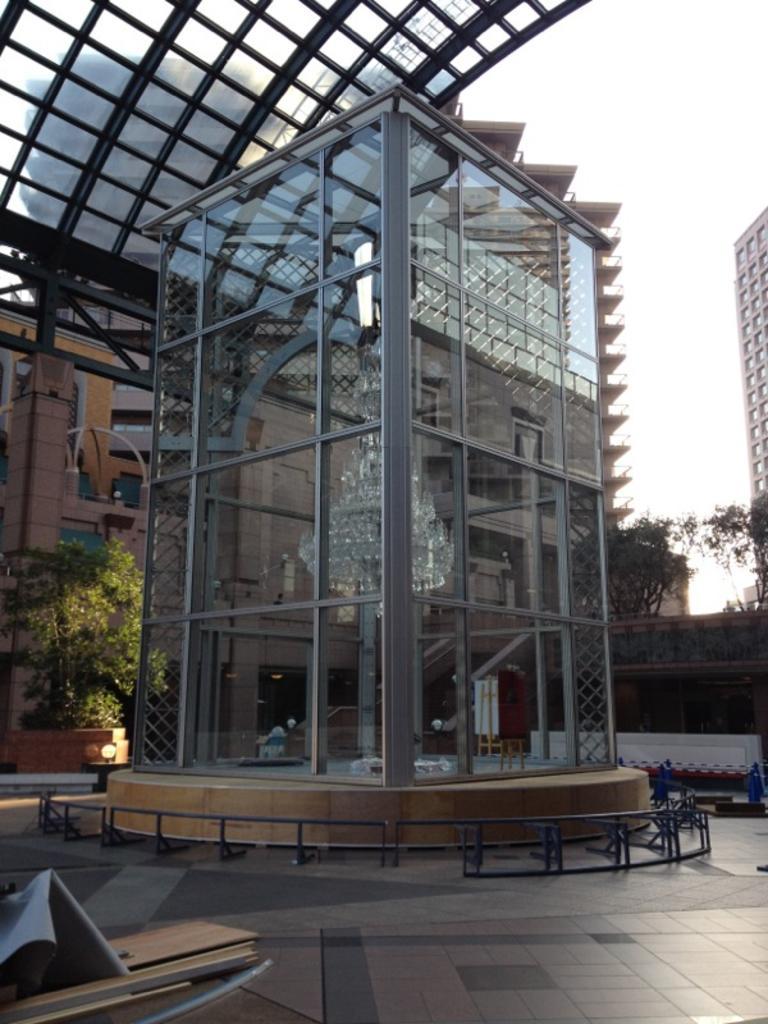Can you describe this image briefly? In this picture we can see few buildings, and we can see a chandelier light in the building, in the background we can see few trees, metal rods and lights. 